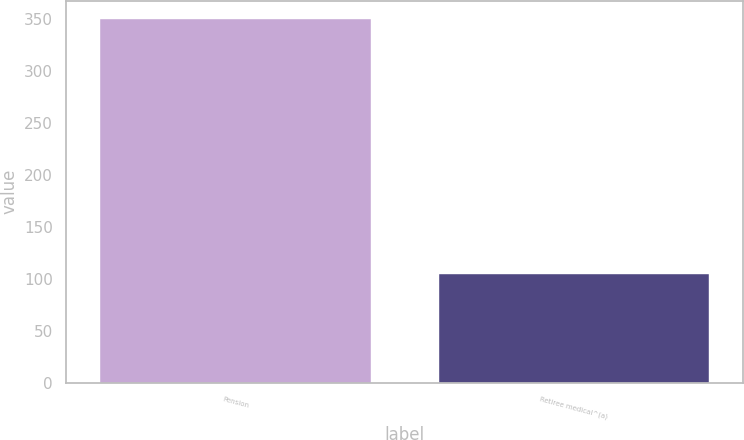Convert chart to OTSL. <chart><loc_0><loc_0><loc_500><loc_500><bar_chart><fcel>Pension<fcel>Retiree medical^(a)<nl><fcel>350<fcel>105<nl></chart> 